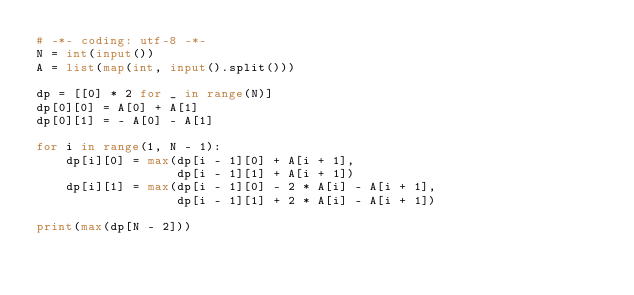<code> <loc_0><loc_0><loc_500><loc_500><_Python_># -*- coding: utf-8 -*-
N = int(input())
A = list(map(int, input().split()))

dp = [[0] * 2 for _ in range(N)]
dp[0][0] = A[0] + A[1]
dp[0][1] = - A[0] - A[1]

for i in range(1, N - 1):
    dp[i][0] = max(dp[i - 1][0] + A[i + 1],
                   dp[i - 1][1] + A[i + 1])
    dp[i][1] = max(dp[i - 1][0] - 2 * A[i] - A[i + 1],
                   dp[i - 1][1] + 2 * A[i] - A[i + 1])

print(max(dp[N - 2]))</code> 